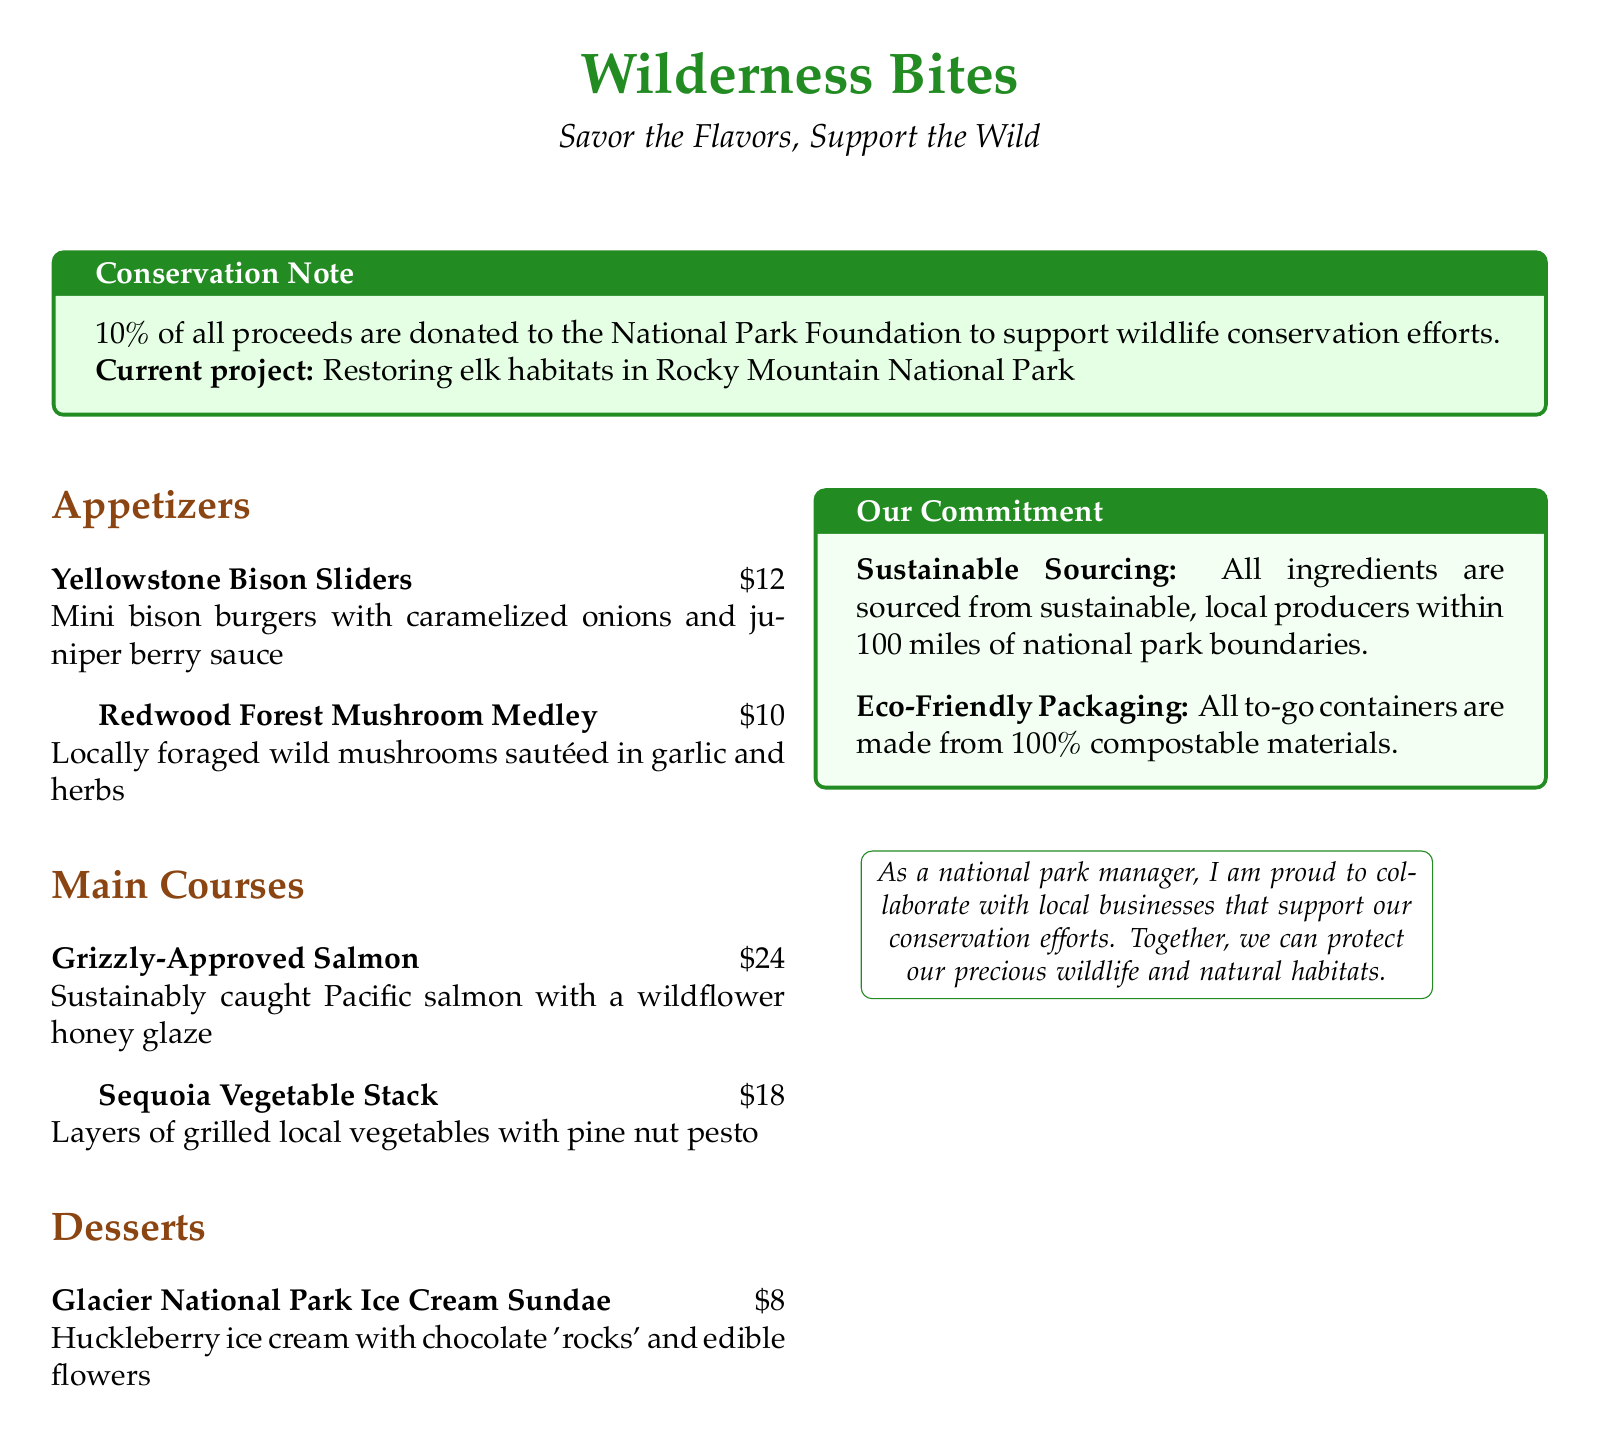What is the name of the restaurant? The name of the restaurant is featured prominently at the top of the menu.
Answer: Wilderness Bites What percentage of proceeds is donated to conservation efforts? The donation percentage is highlighted in the conservation note section of the menu.
Answer: 10% What is the current project supported by the donations? The current project is specified in the conservation note.
Answer: Restoring elk habitats in Rocky Mountain National Park What are the two appetizers listed on the menu? The appetizers are listed in the appetizers section of the menu.
Answer: Yellowstone Bison Sliders, Redwood Forest Mushroom Medley How much does the Grizzly-Approved Salmon cost? The cost of the main course is mentioned next to the dish name in the main courses section.
Answer: $24 What types of materials are used for to-go containers? The information about to-go containers is provided in the commitment section.
Answer: 100% compostable materials Which dessert includes huckleberry? The dessert that includes huckleberry is mentioned in the dessert section.
Answer: Glacier National Park Ice Cream Sundae What is the primary focus of the sustainable sourcing note? The focus of sustainable sourcing is described in the commitment section of the menu.
Answer: Local producers within 100 miles of national park boundaries 